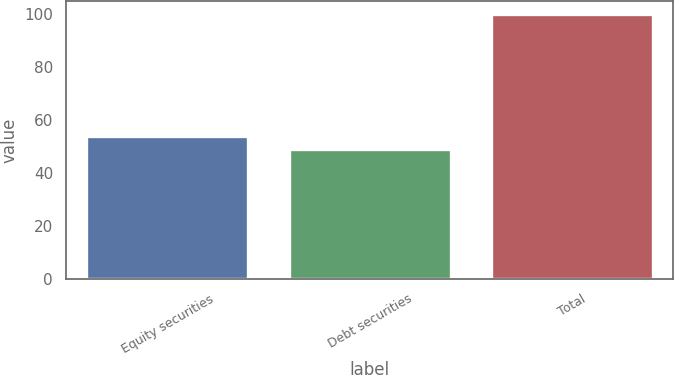Convert chart to OTSL. <chart><loc_0><loc_0><loc_500><loc_500><bar_chart><fcel>Equity securities<fcel>Debt securities<fcel>Total<nl><fcel>54.1<fcel>49<fcel>100<nl></chart> 